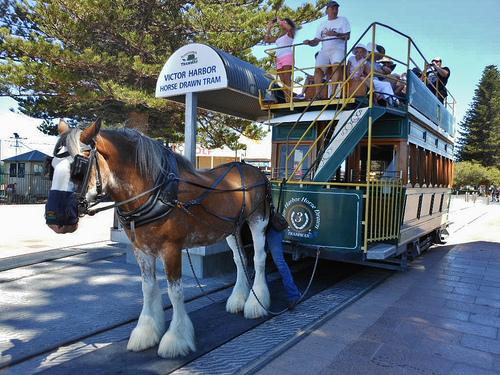In a single sentence, explain the scene involving people on top of the tram. There are tourists on top of the tram, some taking pictures and enjoying the ride, including a woman dressed in pink shorts and a man in a black t-shirt. Describe the additional elements and details of the image related to infrastructure. A green and yellow trolley is present, along with a tram waiting station that has a blue and white shelter, a semi-circle sign with blue letters, and tracks for the tram to travel on. For the multi-choice VQA task, create a question related to the woman on the tram. Answer: c) Pink shorts Narrate a brief storyline for the image depicted. On a sunny day, tourists enjoy a scenic ride on a horse-drawn tram, pulled by a beautiful brown and white Clydesdale. Some passengers capture memories by taking pictures, while they pass by a tram waiting station and lush green trees. If this image were part of a travel magazine, provide a concise caption to describe the scene and promote the experience. "Step back in time: Experience the charm of horse-drawn tram rides and immerse yourself in a picturesque, vintage atmosphere." What is the visual entailment task related to the green tree in the distance? Determine whether the image includes a green tree in the distance and assess its size. Design a product advertisement task using elements from the image. Create an advertisement for a vintage-inspired horse-drawn tram tour company, showcasing the experience of riding a tram pulled by a majestic Clydesdale horse. Identify the primary mode of transportation depicted in the image. The primary mode of transportation is a horse-drawn tram. Express what makes the horse unique and what it's currently engaged in. The brown and white Clydesdale horse has large, hairy hooves and is wearing blinders. It's currently pulling the tram. 